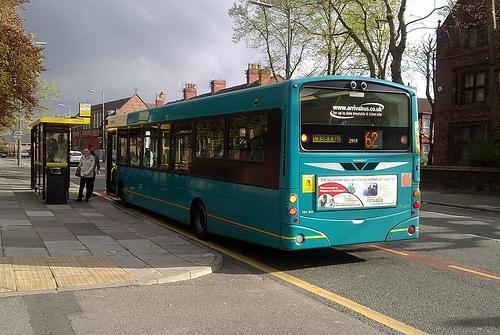How many passengers are boarding the bus?
Give a very brief answer. 2. 